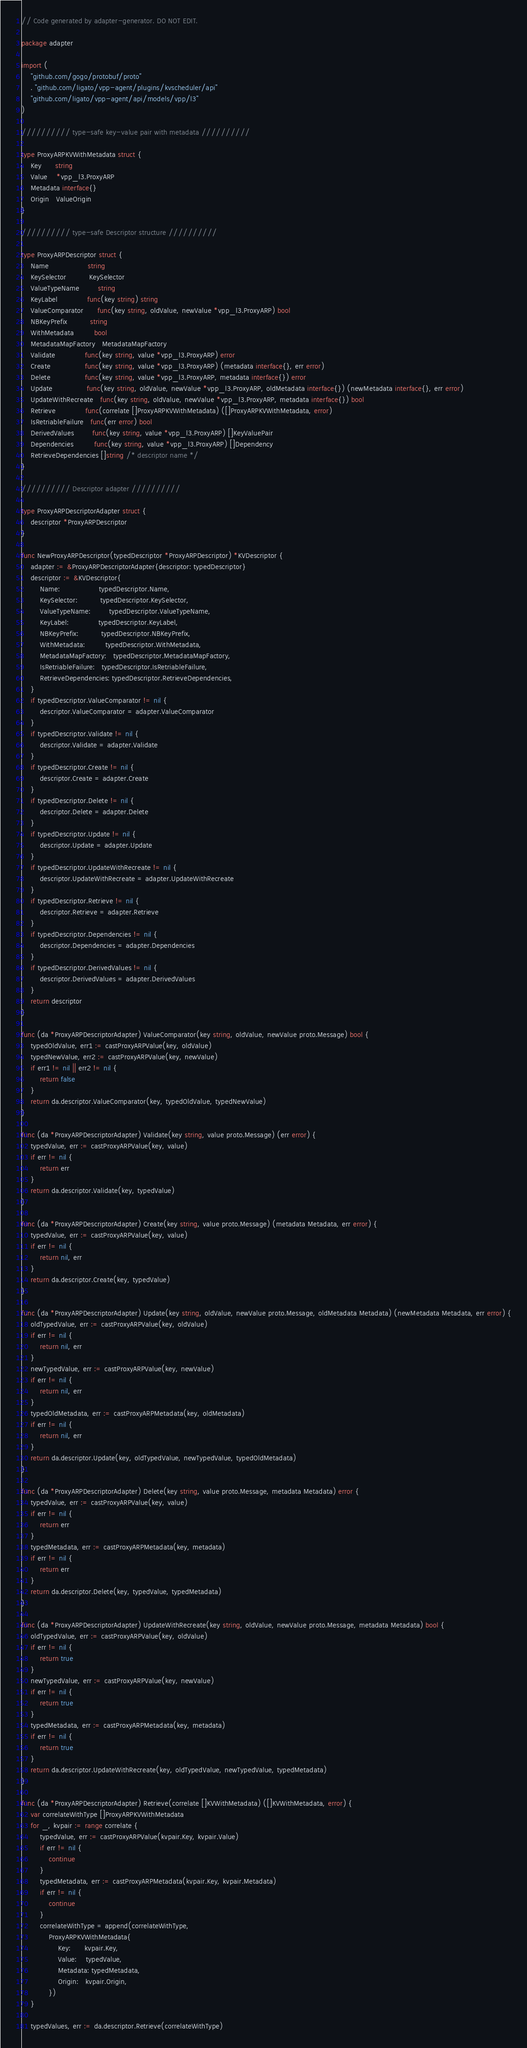Convert code to text. <code><loc_0><loc_0><loc_500><loc_500><_Go_>// Code generated by adapter-generator. DO NOT EDIT.

package adapter

import (
	"github.com/gogo/protobuf/proto"
	. "github.com/ligato/vpp-agent/plugins/kvscheduler/api"
	"github.com/ligato/vpp-agent/api/models/vpp/l3"
)

////////// type-safe key-value pair with metadata //////////

type ProxyARPKVWithMetadata struct {
	Key      string
	Value    *vpp_l3.ProxyARP
	Metadata interface{}
	Origin   ValueOrigin
}

////////// type-safe Descriptor structure //////////

type ProxyARPDescriptor struct {
	Name                 string
	KeySelector          KeySelector
	ValueTypeName        string
	KeyLabel             func(key string) string
	ValueComparator      func(key string, oldValue, newValue *vpp_l3.ProxyARP) bool
	NBKeyPrefix          string
	WithMetadata         bool
	MetadataMapFactory   MetadataMapFactory
	Validate             func(key string, value *vpp_l3.ProxyARP) error
	Create               func(key string, value *vpp_l3.ProxyARP) (metadata interface{}, err error)
	Delete               func(key string, value *vpp_l3.ProxyARP, metadata interface{}) error
	Update               func(key string, oldValue, newValue *vpp_l3.ProxyARP, oldMetadata interface{}) (newMetadata interface{}, err error)
	UpdateWithRecreate   func(key string, oldValue, newValue *vpp_l3.ProxyARP, metadata interface{}) bool
	Retrieve             func(correlate []ProxyARPKVWithMetadata) ([]ProxyARPKVWithMetadata, error)
	IsRetriableFailure   func(err error) bool
	DerivedValues        func(key string, value *vpp_l3.ProxyARP) []KeyValuePair
	Dependencies         func(key string, value *vpp_l3.ProxyARP) []Dependency
	RetrieveDependencies []string /* descriptor name */
}

////////// Descriptor adapter //////////

type ProxyARPDescriptorAdapter struct {
	descriptor *ProxyARPDescriptor
}

func NewProxyARPDescriptor(typedDescriptor *ProxyARPDescriptor) *KVDescriptor {
	adapter := &ProxyARPDescriptorAdapter{descriptor: typedDescriptor}
	descriptor := &KVDescriptor{
		Name:                 typedDescriptor.Name,
		KeySelector:          typedDescriptor.KeySelector,
		ValueTypeName:        typedDescriptor.ValueTypeName,
		KeyLabel:             typedDescriptor.KeyLabel,
		NBKeyPrefix:          typedDescriptor.NBKeyPrefix,
		WithMetadata:         typedDescriptor.WithMetadata,
		MetadataMapFactory:   typedDescriptor.MetadataMapFactory,
		IsRetriableFailure:   typedDescriptor.IsRetriableFailure,
		RetrieveDependencies: typedDescriptor.RetrieveDependencies,
	}
	if typedDescriptor.ValueComparator != nil {
		descriptor.ValueComparator = adapter.ValueComparator
	}
	if typedDescriptor.Validate != nil {
		descriptor.Validate = adapter.Validate
	}
	if typedDescriptor.Create != nil {
		descriptor.Create = adapter.Create
	}
	if typedDescriptor.Delete != nil {
		descriptor.Delete = adapter.Delete
	}
	if typedDescriptor.Update != nil {
		descriptor.Update = adapter.Update
	}
	if typedDescriptor.UpdateWithRecreate != nil {
		descriptor.UpdateWithRecreate = adapter.UpdateWithRecreate
	}
	if typedDescriptor.Retrieve != nil {
		descriptor.Retrieve = adapter.Retrieve
	}
	if typedDescriptor.Dependencies != nil {
		descriptor.Dependencies = adapter.Dependencies
	}
	if typedDescriptor.DerivedValues != nil {
		descriptor.DerivedValues = adapter.DerivedValues
	}
	return descriptor
}

func (da *ProxyARPDescriptorAdapter) ValueComparator(key string, oldValue, newValue proto.Message) bool {
	typedOldValue, err1 := castProxyARPValue(key, oldValue)
	typedNewValue, err2 := castProxyARPValue(key, newValue)
	if err1 != nil || err2 != nil {
		return false
	}
	return da.descriptor.ValueComparator(key, typedOldValue, typedNewValue)
}

func (da *ProxyARPDescriptorAdapter) Validate(key string, value proto.Message) (err error) {
	typedValue, err := castProxyARPValue(key, value)
	if err != nil {
		return err
	}
	return da.descriptor.Validate(key, typedValue)
}

func (da *ProxyARPDescriptorAdapter) Create(key string, value proto.Message) (metadata Metadata, err error) {
	typedValue, err := castProxyARPValue(key, value)
	if err != nil {
		return nil, err
	}
	return da.descriptor.Create(key, typedValue)
}

func (da *ProxyARPDescriptorAdapter) Update(key string, oldValue, newValue proto.Message, oldMetadata Metadata) (newMetadata Metadata, err error) {
	oldTypedValue, err := castProxyARPValue(key, oldValue)
	if err != nil {
		return nil, err
	}
	newTypedValue, err := castProxyARPValue(key, newValue)
	if err != nil {
		return nil, err
	}
	typedOldMetadata, err := castProxyARPMetadata(key, oldMetadata)
	if err != nil {
		return nil, err
	}
	return da.descriptor.Update(key, oldTypedValue, newTypedValue, typedOldMetadata)
}

func (da *ProxyARPDescriptorAdapter) Delete(key string, value proto.Message, metadata Metadata) error {
	typedValue, err := castProxyARPValue(key, value)
	if err != nil {
		return err
	}
	typedMetadata, err := castProxyARPMetadata(key, metadata)
	if err != nil {
		return err
	}
	return da.descriptor.Delete(key, typedValue, typedMetadata)
}

func (da *ProxyARPDescriptorAdapter) UpdateWithRecreate(key string, oldValue, newValue proto.Message, metadata Metadata) bool {
	oldTypedValue, err := castProxyARPValue(key, oldValue)
	if err != nil {
		return true
	}
	newTypedValue, err := castProxyARPValue(key, newValue)
	if err != nil {
		return true
	}
	typedMetadata, err := castProxyARPMetadata(key, metadata)
	if err != nil {
		return true
	}
	return da.descriptor.UpdateWithRecreate(key, oldTypedValue, newTypedValue, typedMetadata)
}

func (da *ProxyARPDescriptorAdapter) Retrieve(correlate []KVWithMetadata) ([]KVWithMetadata, error) {
	var correlateWithType []ProxyARPKVWithMetadata
	for _, kvpair := range correlate {
		typedValue, err := castProxyARPValue(kvpair.Key, kvpair.Value)
		if err != nil {
			continue
		}
		typedMetadata, err := castProxyARPMetadata(kvpair.Key, kvpair.Metadata)
		if err != nil {
			continue
		}
		correlateWithType = append(correlateWithType,
			ProxyARPKVWithMetadata{
				Key:      kvpair.Key,
				Value:    typedValue,
				Metadata: typedMetadata,
				Origin:   kvpair.Origin,
			})
	}

	typedValues, err := da.descriptor.Retrieve(correlateWithType)</code> 